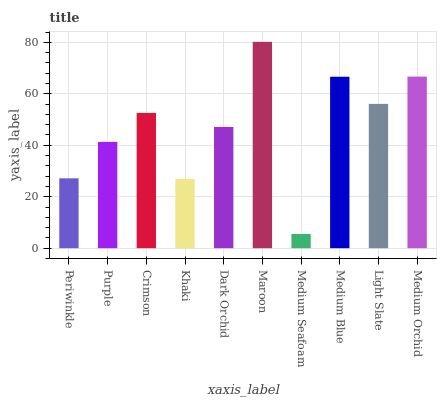Is Medium Seafoam the minimum?
Answer yes or no. Yes. Is Maroon the maximum?
Answer yes or no. Yes. Is Purple the minimum?
Answer yes or no. No. Is Purple the maximum?
Answer yes or no. No. Is Purple greater than Periwinkle?
Answer yes or no. Yes. Is Periwinkle less than Purple?
Answer yes or no. Yes. Is Periwinkle greater than Purple?
Answer yes or no. No. Is Purple less than Periwinkle?
Answer yes or no. No. Is Crimson the high median?
Answer yes or no. Yes. Is Dark Orchid the low median?
Answer yes or no. Yes. Is Light Slate the high median?
Answer yes or no. No. Is Medium Orchid the low median?
Answer yes or no. No. 